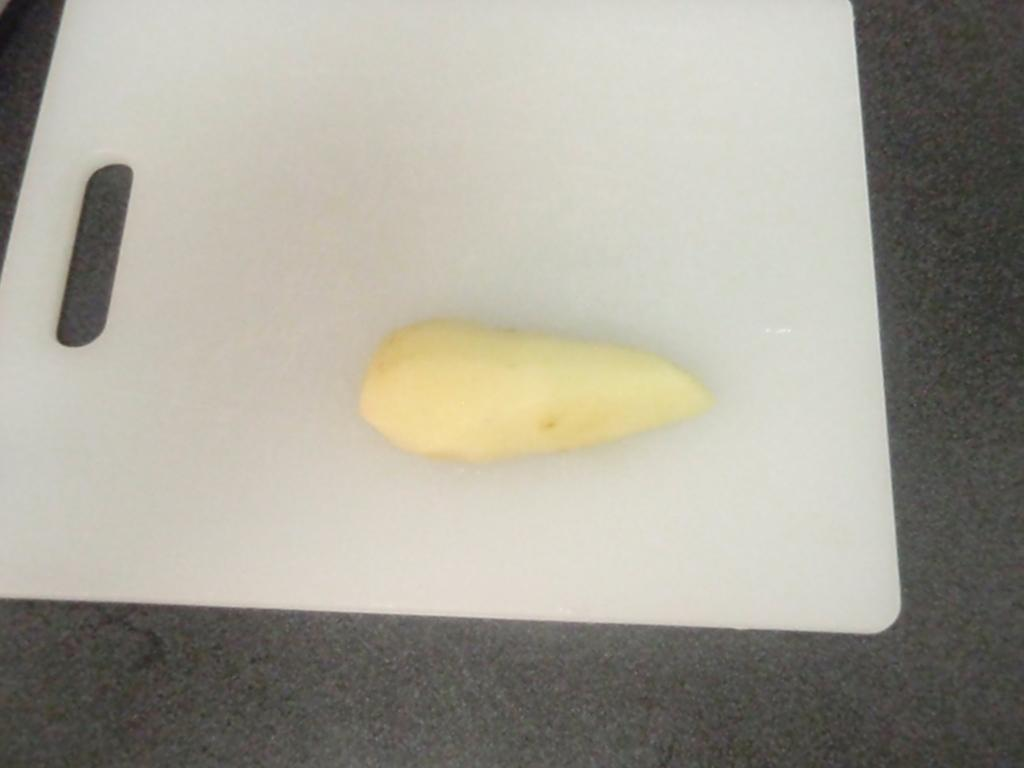What type of food can be seen on the chopping board in the image? There are vegetables on a chopping board in the image. What type of paint is being used to color the map on the scarf in the image? There is no map, paint, or scarf present in the image; it only features vegetables on a chopping board. 